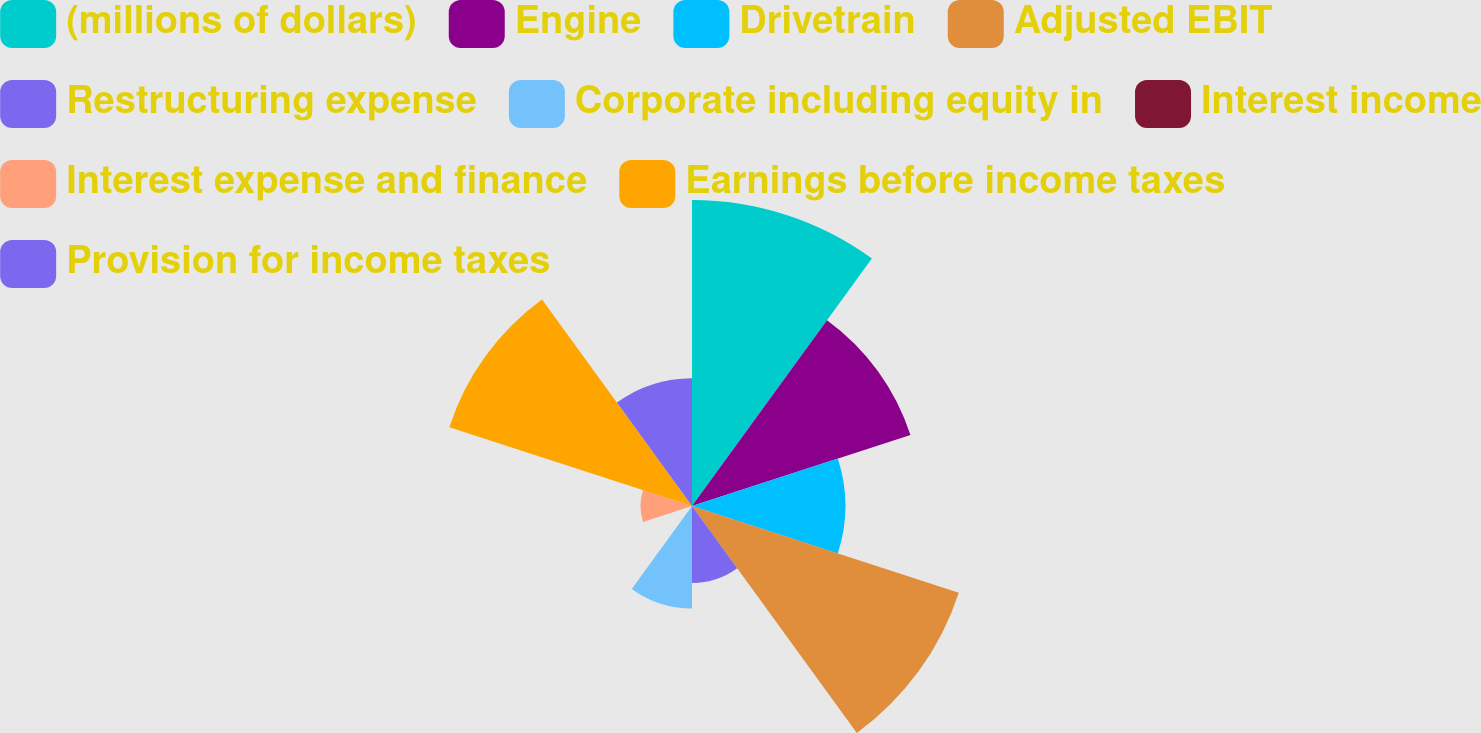Convert chart to OTSL. <chart><loc_0><loc_0><loc_500><loc_500><pie_chart><fcel>(millions of dollars)<fcel>Engine<fcel>Drivetrain<fcel>Adjusted EBIT<fcel>Restructuring expense<fcel>Corporate including equity in<fcel>Interest income<fcel>Interest expense and finance<fcel>Earnings before income taxes<fcel>Provision for income taxes<nl><fcel>19.32%<fcel>14.5%<fcel>9.68%<fcel>17.71%<fcel>4.86%<fcel>6.47%<fcel>0.04%<fcel>3.25%<fcel>16.11%<fcel>8.07%<nl></chart> 